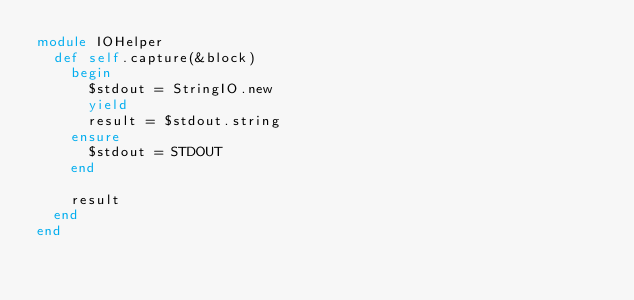Convert code to text. <code><loc_0><loc_0><loc_500><loc_500><_Ruby_>module IOHelper
  def self.capture(&block)
    begin
      $stdout = StringIO.new
      yield
      result = $stdout.string
    ensure
      $stdout = STDOUT
    end

    result
  end
end

</code> 